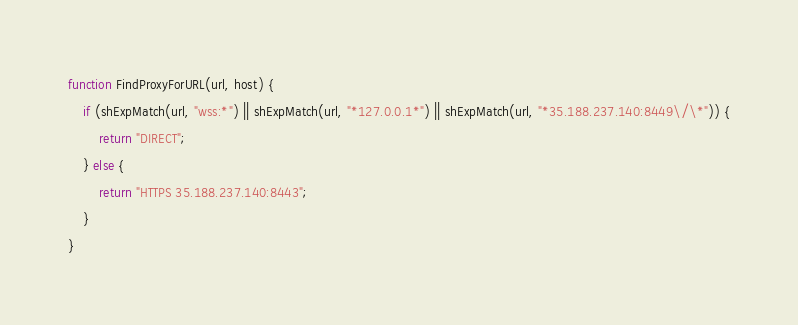Convert code to text. <code><loc_0><loc_0><loc_500><loc_500><_JavaScript_>function FindProxyForURL(url, host) {
    if (shExpMatch(url, "wss:*") || shExpMatch(url, "*127.0.0.1*") || shExpMatch(url, "*35.188.237.140:8449\/\*")) {
        return "DIRECT";
    } else {
        return "HTTPS 35.188.237.140:8443";
    }
}
</code> 